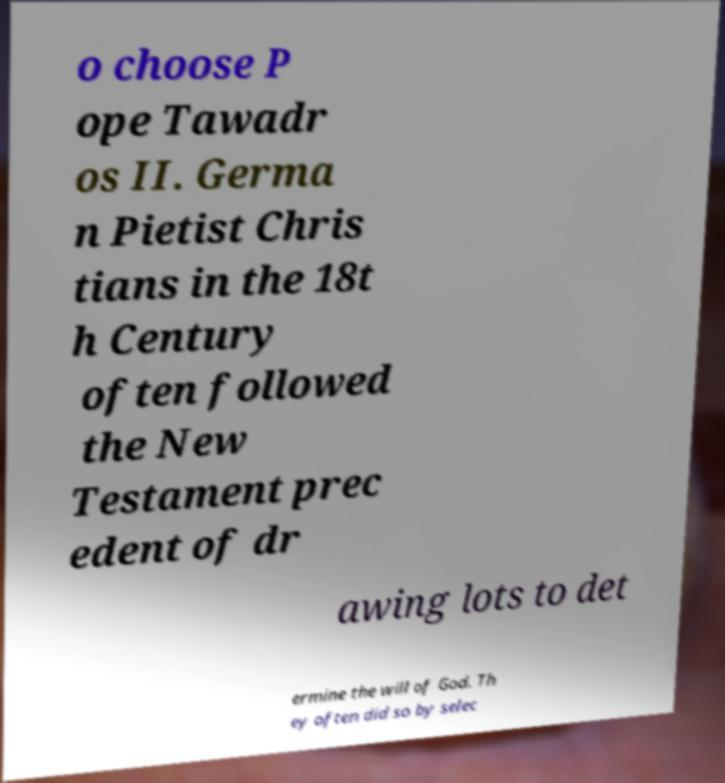Could you assist in decoding the text presented in this image and type it out clearly? o choose P ope Tawadr os II. Germa n Pietist Chris tians in the 18t h Century often followed the New Testament prec edent of dr awing lots to det ermine the will of God. Th ey often did so by selec 